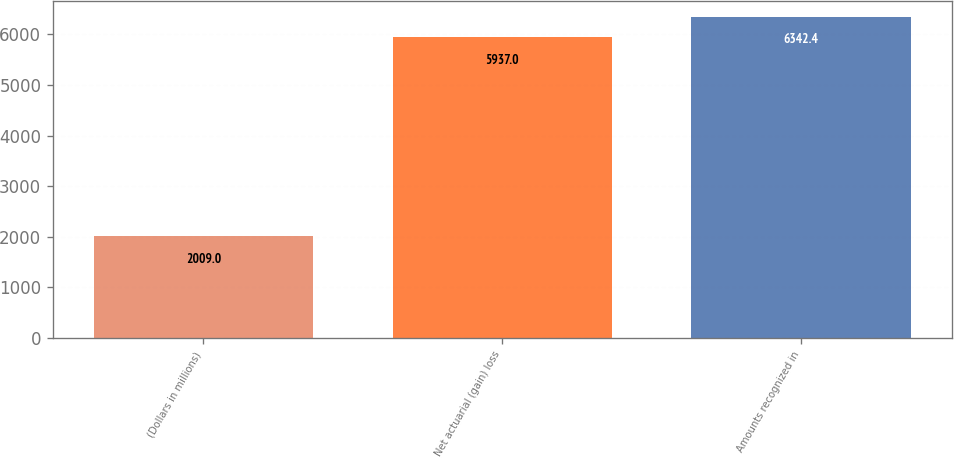Convert chart to OTSL. <chart><loc_0><loc_0><loc_500><loc_500><bar_chart><fcel>(Dollars in millions)<fcel>Net actuarial (gain) loss<fcel>Amounts recognized in<nl><fcel>2009<fcel>5937<fcel>6342.4<nl></chart> 